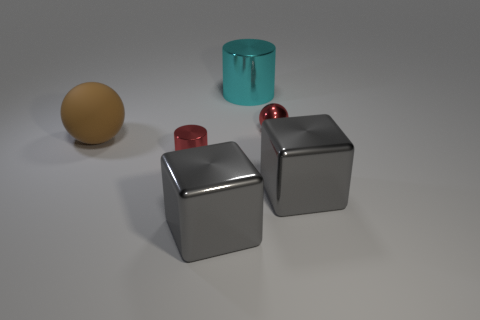Subtract 2 cubes. How many cubes are left? 0 Add 5 cyan metal cylinders. How many cyan metal cylinders are left? 6 Add 5 large green matte things. How many large green matte things exist? 5 Add 3 brown blocks. How many objects exist? 9 Subtract 0 blue spheres. How many objects are left? 6 Subtract all cylinders. How many objects are left? 4 Subtract all blue cylinders. Subtract all green spheres. How many cylinders are left? 2 Subtract all green cylinders. How many green cubes are left? 0 Subtract all large metallic blocks. Subtract all shiny blocks. How many objects are left? 2 